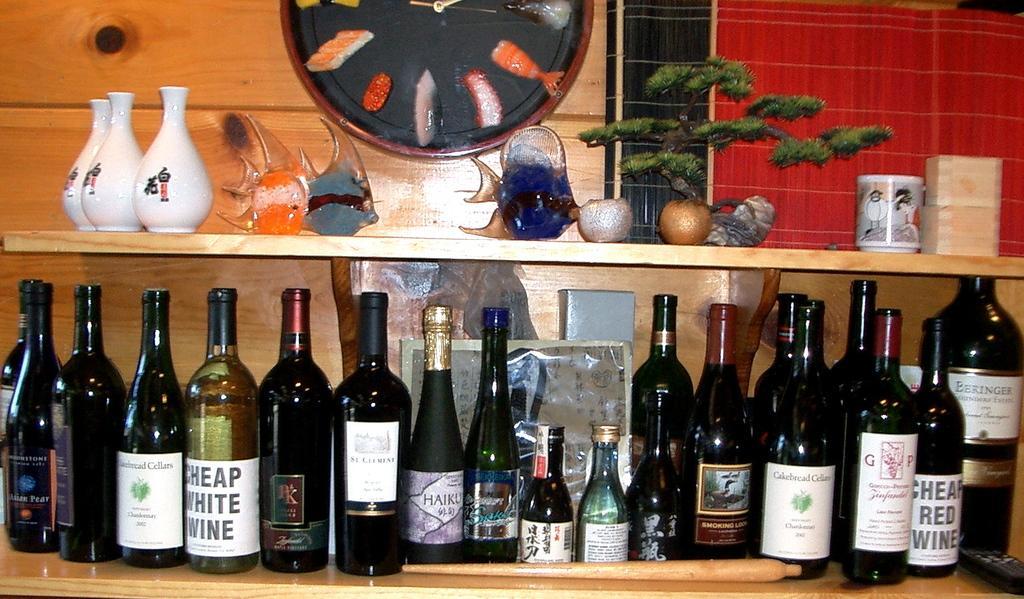Can you describe this image briefly? In this picture we can see two racks. On the top we can see few white colour pots ,fishes, plants and cup show pieces. At the down rack we can see bottles arranged in a sequence manner. 